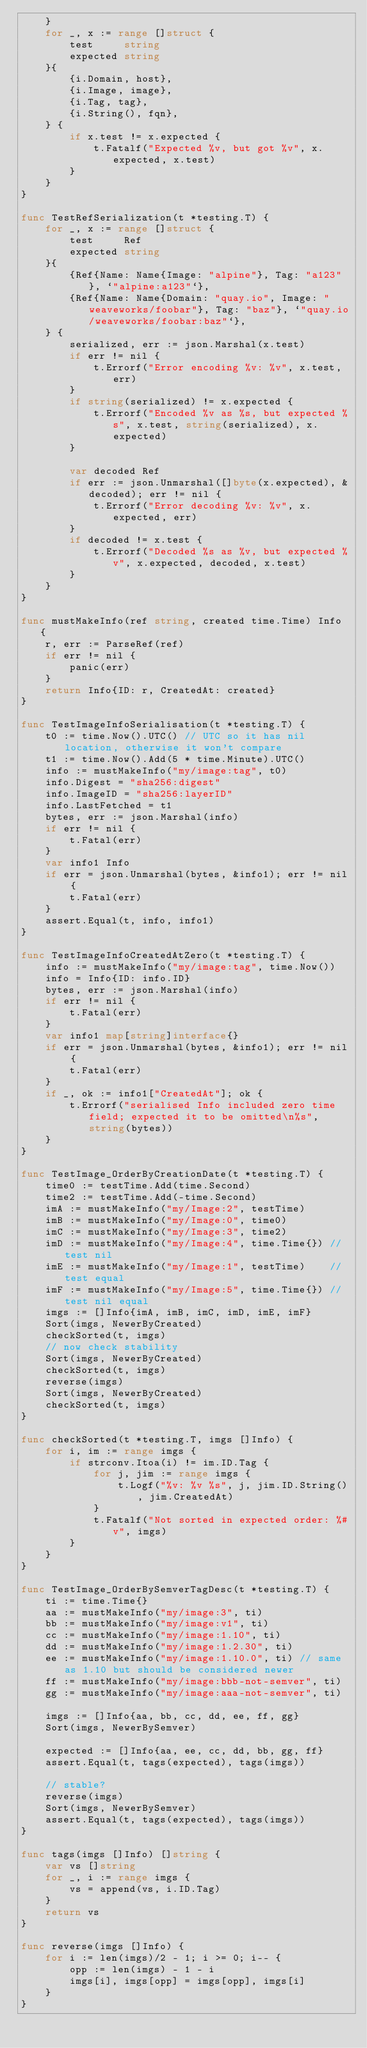Convert code to text. <code><loc_0><loc_0><loc_500><loc_500><_Go_>	}
	for _, x := range []struct {
		test     string
		expected string
	}{
		{i.Domain, host},
		{i.Image, image},
		{i.Tag, tag},
		{i.String(), fqn},
	} {
		if x.test != x.expected {
			t.Fatalf("Expected %v, but got %v", x.expected, x.test)
		}
	}
}

func TestRefSerialization(t *testing.T) {
	for _, x := range []struct {
		test     Ref
		expected string
	}{
		{Ref{Name: Name{Image: "alpine"}, Tag: "a123"}, `"alpine:a123"`},
		{Ref{Name: Name{Domain: "quay.io", Image: "weaveworks/foobar"}, Tag: "baz"}, `"quay.io/weaveworks/foobar:baz"`},
	} {
		serialized, err := json.Marshal(x.test)
		if err != nil {
			t.Errorf("Error encoding %v: %v", x.test, err)
		}
		if string(serialized) != x.expected {
			t.Errorf("Encoded %v as %s, but expected %s", x.test, string(serialized), x.expected)
		}

		var decoded Ref
		if err := json.Unmarshal([]byte(x.expected), &decoded); err != nil {
			t.Errorf("Error decoding %v: %v", x.expected, err)
		}
		if decoded != x.test {
			t.Errorf("Decoded %s as %v, but expected %v", x.expected, decoded, x.test)
		}
	}
}

func mustMakeInfo(ref string, created time.Time) Info {
	r, err := ParseRef(ref)
	if err != nil {
		panic(err)
	}
	return Info{ID: r, CreatedAt: created}
}

func TestImageInfoSerialisation(t *testing.T) {
	t0 := time.Now().UTC() // UTC so it has nil location, otherwise it won't compare
	t1 := time.Now().Add(5 * time.Minute).UTC()
	info := mustMakeInfo("my/image:tag", t0)
	info.Digest = "sha256:digest"
	info.ImageID = "sha256:layerID"
	info.LastFetched = t1
	bytes, err := json.Marshal(info)
	if err != nil {
		t.Fatal(err)
	}
	var info1 Info
	if err = json.Unmarshal(bytes, &info1); err != nil {
		t.Fatal(err)
	}
	assert.Equal(t, info, info1)
}

func TestImageInfoCreatedAtZero(t *testing.T) {
	info := mustMakeInfo("my/image:tag", time.Now())
	info = Info{ID: info.ID}
	bytes, err := json.Marshal(info)
	if err != nil {
		t.Fatal(err)
	}
	var info1 map[string]interface{}
	if err = json.Unmarshal(bytes, &info1); err != nil {
		t.Fatal(err)
	}
	if _, ok := info1["CreatedAt"]; ok {
		t.Errorf("serialised Info included zero time field; expected it to be omitted\n%s", string(bytes))
	}
}

func TestImage_OrderByCreationDate(t *testing.T) {
	time0 := testTime.Add(time.Second)
	time2 := testTime.Add(-time.Second)
	imA := mustMakeInfo("my/Image:2", testTime)
	imB := mustMakeInfo("my/Image:0", time0)
	imC := mustMakeInfo("my/Image:3", time2)
	imD := mustMakeInfo("my/Image:4", time.Time{}) // test nil
	imE := mustMakeInfo("my/Image:1", testTime)    // test equal
	imF := mustMakeInfo("my/Image:5", time.Time{}) // test nil equal
	imgs := []Info{imA, imB, imC, imD, imE, imF}
	Sort(imgs, NewerByCreated)
	checkSorted(t, imgs)
	// now check stability
	Sort(imgs, NewerByCreated)
	checkSorted(t, imgs)
	reverse(imgs)
	Sort(imgs, NewerByCreated)
	checkSorted(t, imgs)
}

func checkSorted(t *testing.T, imgs []Info) {
	for i, im := range imgs {
		if strconv.Itoa(i) != im.ID.Tag {
			for j, jim := range imgs {
				t.Logf("%v: %v %s", j, jim.ID.String(), jim.CreatedAt)
			}
			t.Fatalf("Not sorted in expected order: %#v", imgs)
		}
	}
}

func TestImage_OrderBySemverTagDesc(t *testing.T) {
	ti := time.Time{}
	aa := mustMakeInfo("my/image:3", ti)
	bb := mustMakeInfo("my/image:v1", ti)
	cc := mustMakeInfo("my/image:1.10", ti)
	dd := mustMakeInfo("my/image:1.2.30", ti)
	ee := mustMakeInfo("my/image:1.10.0", ti) // same as 1.10 but should be considered newer
	ff := mustMakeInfo("my/image:bbb-not-semver", ti)
	gg := mustMakeInfo("my/image:aaa-not-semver", ti)

	imgs := []Info{aa, bb, cc, dd, ee, ff, gg}
	Sort(imgs, NewerBySemver)

	expected := []Info{aa, ee, cc, dd, bb, gg, ff}
	assert.Equal(t, tags(expected), tags(imgs))

	// stable?
	reverse(imgs)
	Sort(imgs, NewerBySemver)
	assert.Equal(t, tags(expected), tags(imgs))
}

func tags(imgs []Info) []string {
	var vs []string
	for _, i := range imgs {
		vs = append(vs, i.ID.Tag)
	}
	return vs
}

func reverse(imgs []Info) {
	for i := len(imgs)/2 - 1; i >= 0; i-- {
		opp := len(imgs) - 1 - i
		imgs[i], imgs[opp] = imgs[opp], imgs[i]
	}
}
</code> 